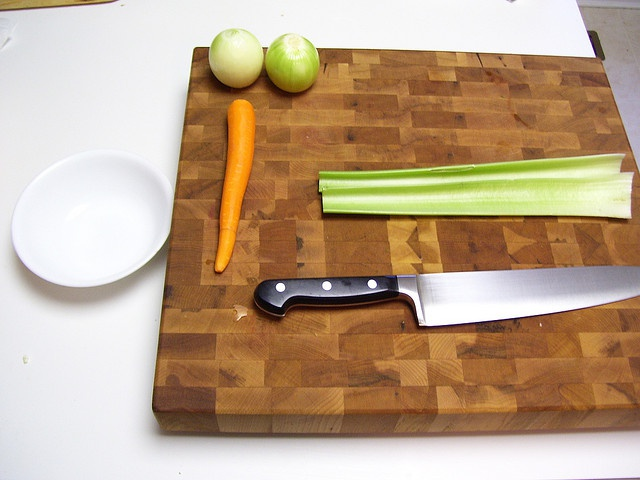Describe the objects in this image and their specific colors. I can see bowl in olive, white, darkgray, and gray tones, knife in olive, white, darkgray, black, and gray tones, and carrot in olive, orange, and red tones in this image. 